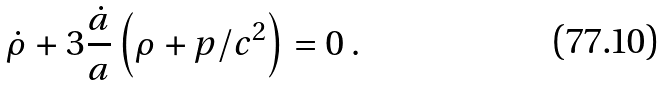<formula> <loc_0><loc_0><loc_500><loc_500>\dot { \rho } + 3 \frac { \dot { a } } { a } \left ( \rho + p / c ^ { 2 } \right ) = 0 \, .</formula> 